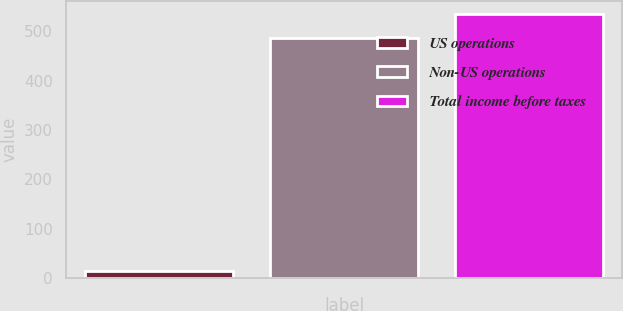Convert chart. <chart><loc_0><loc_0><loc_500><loc_500><bar_chart><fcel>US operations<fcel>Non-US operations<fcel>Total income before taxes<nl><fcel>14<fcel>487<fcel>535.7<nl></chart> 